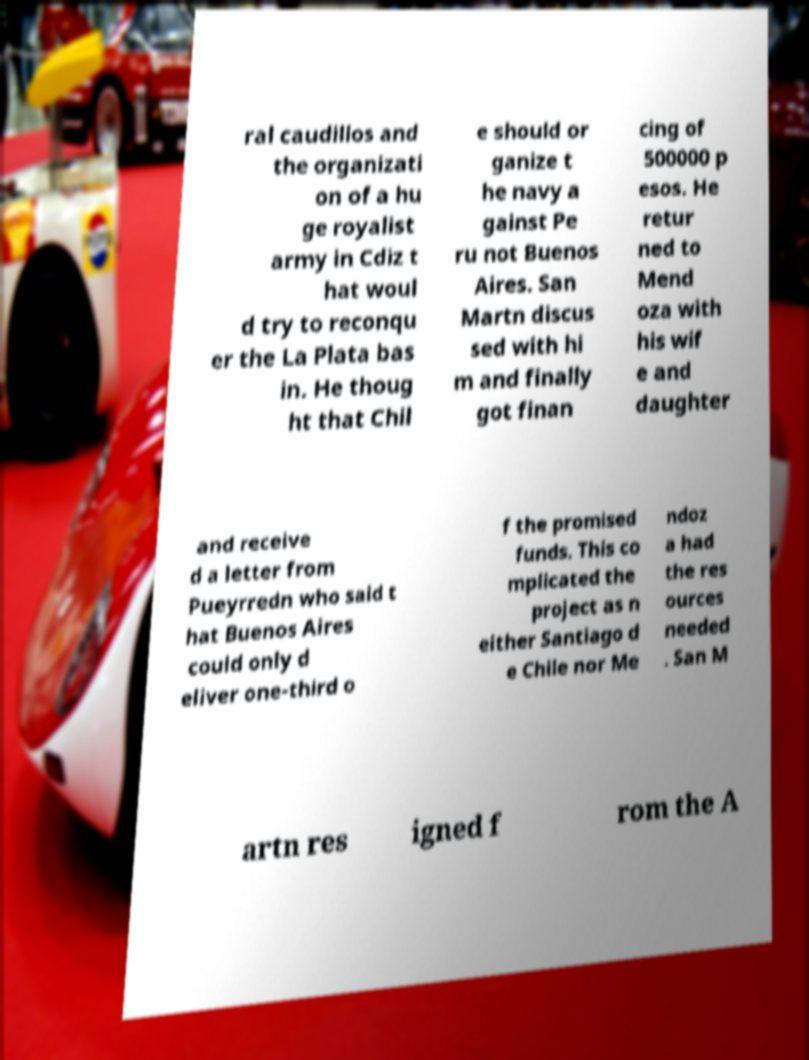Could you assist in decoding the text presented in this image and type it out clearly? ral caudillos and the organizati on of a hu ge royalist army in Cdiz t hat woul d try to reconqu er the La Plata bas in. He thoug ht that Chil e should or ganize t he navy a gainst Pe ru not Buenos Aires. San Martn discus sed with hi m and finally got finan cing of 500000 p esos. He retur ned to Mend oza with his wif e and daughter and receive d a letter from Pueyrredn who said t hat Buenos Aires could only d eliver one-third o f the promised funds. This co mplicated the project as n either Santiago d e Chile nor Me ndoz a had the res ources needed . San M artn res igned f rom the A 